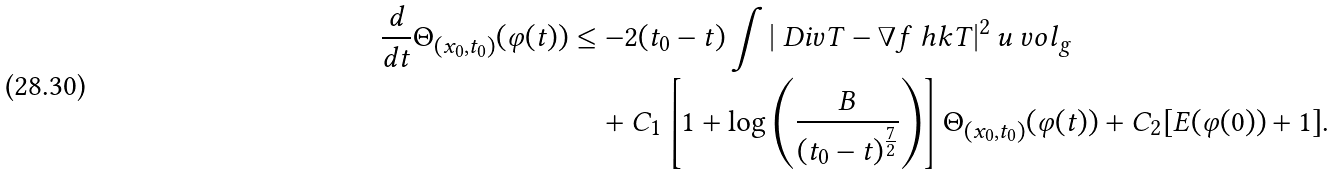Convert formula to latex. <formula><loc_0><loc_0><loc_500><loc_500>\frac { d } { d t } \Theta _ { ( x _ { 0 } , t _ { 0 } ) } ( \varphi ( t ) ) & \leq - 2 ( t _ { 0 } - t ) \int \left | \ D i v T - \nabla f \ h k T \right | ^ { 2 } u \ v o l _ { g } \\ & \quad + C _ { 1 } \left [ 1 + \log \left ( \frac { B } { ( t _ { 0 } - t ) ^ { \frac { 7 } { 2 } } } \right ) \right ] \Theta _ { ( x _ { 0 } , t _ { 0 } ) } ( \varphi ( t ) ) + C _ { 2 } [ E ( \varphi ( 0 ) ) + 1 ] .</formula> 